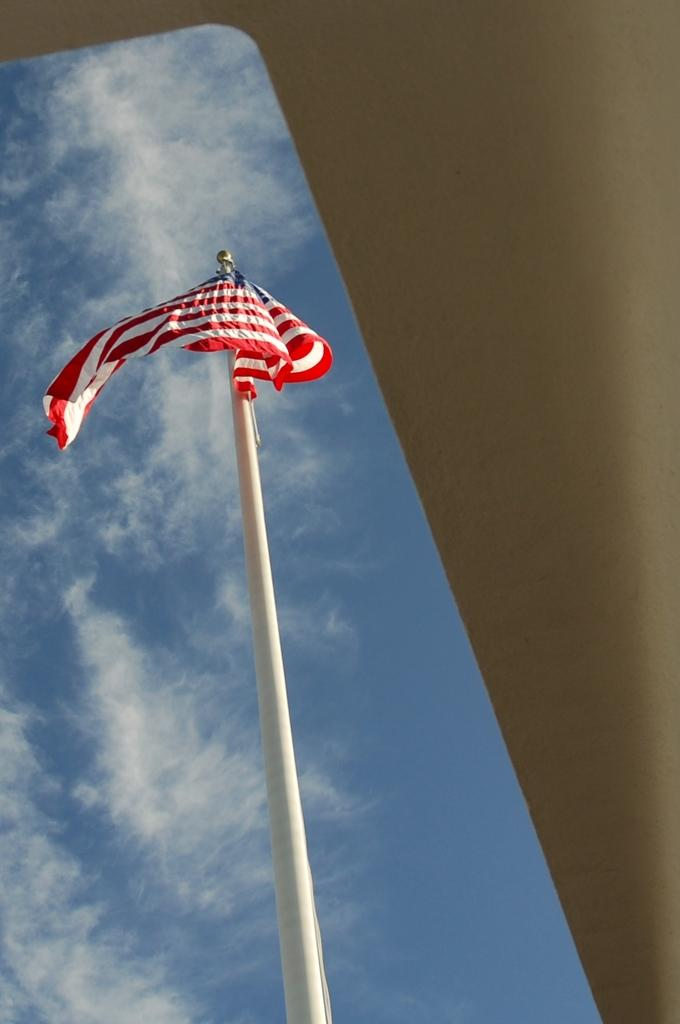What is the main object in the image? There is a white color pole in the image. What is attached to the pole? There is a flag on the pole. What can be seen in the background of the image? The background of the image includes a blue color sky. What type of apparatus is used to extract honey from the pole in the image? There is no apparatus or honey present in the image; it features a white color pole with a flag and a blue color sky in the background. 